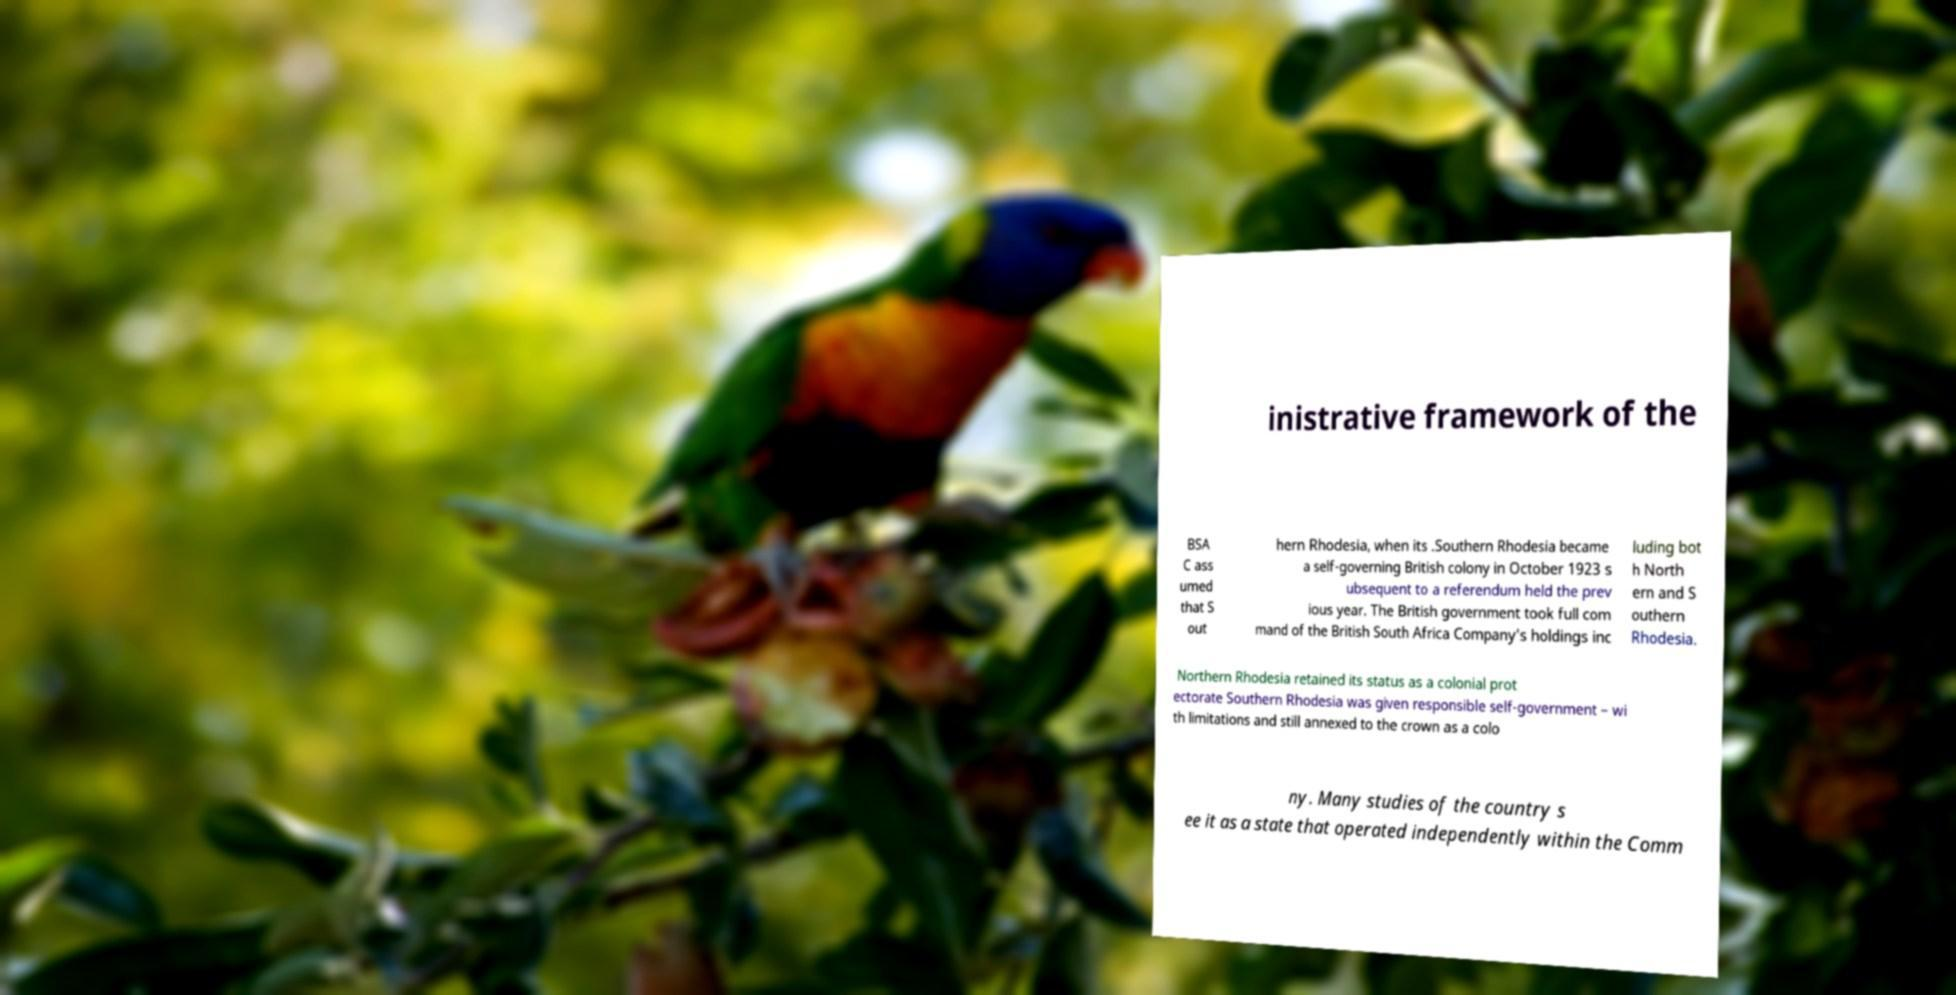What messages or text are displayed in this image? I need them in a readable, typed format. inistrative framework of the BSA C ass umed that S out hern Rhodesia, when its .Southern Rhodesia became a self-governing British colony in October 1923 s ubsequent to a referendum held the prev ious year. The British government took full com mand of the British South Africa Company's holdings inc luding bot h North ern and S outhern Rhodesia. Northern Rhodesia retained its status as a colonial prot ectorate Southern Rhodesia was given responsible self-government – wi th limitations and still annexed to the crown as a colo ny. Many studies of the country s ee it as a state that operated independently within the Comm 